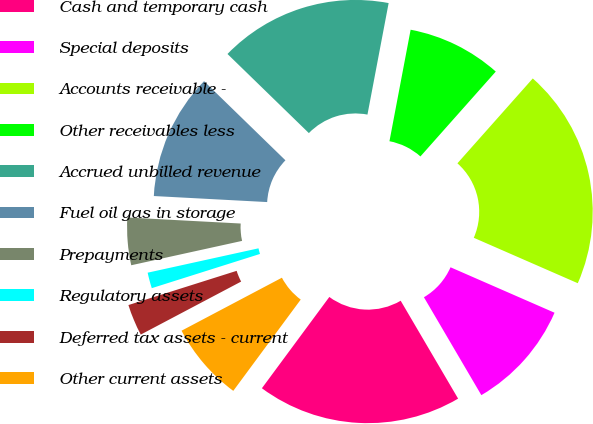Convert chart to OTSL. <chart><loc_0><loc_0><loc_500><loc_500><pie_chart><fcel>Cash and temporary cash<fcel>Special deposits<fcel>Accounts receivable -<fcel>Other receivables less<fcel>Accrued unbilled revenue<fcel>Fuel oil gas in storage<fcel>Prepayments<fcel>Regulatory assets<fcel>Deferred tax assets - current<fcel>Other current assets<nl><fcel>18.57%<fcel>10.0%<fcel>20.0%<fcel>8.57%<fcel>15.71%<fcel>11.43%<fcel>4.29%<fcel>1.43%<fcel>2.86%<fcel>7.14%<nl></chart> 